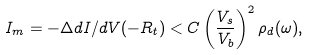<formula> <loc_0><loc_0><loc_500><loc_500>I _ { m } = - \Delta d I / d V ( - R _ { t } ) < C \left ( \frac { V _ { s } } { V _ { b } } \right ) ^ { 2 } \rho _ { d } ( \omega ) ,</formula> 